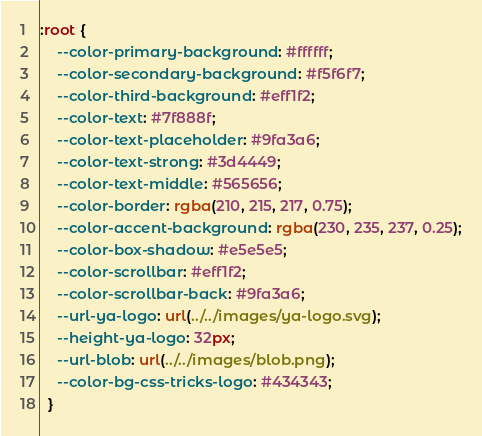<code> <loc_0><loc_0><loc_500><loc_500><_CSS_>:root {
    --color-primary-background: #ffffff;
    --color-secondary-background: #f5f6f7;
    --color-third-background: #eff1f2;
    --color-text: #7f888f;
    --color-text-placeholder: #9fa3a6;
    --color-text-strong: #3d4449;
    --color-text-middle: #565656;
    --color-border: rgba(210, 215, 217, 0.75);
    --color-accent-background: rgba(230, 235, 237, 0.25);
    --color-box-shadow: #e5e5e5;
    --color-scrollbar: #eff1f2;
    --color-scrollbar-back: #9fa3a6;
    --url-ya-logo: url(../../images/ya-logo.svg);
    --height-ya-logo: 32px;
    --url-blob: url(../../images/blob.png);
    --color-bg-css-tricks-logo: #434343;
  }</code> 